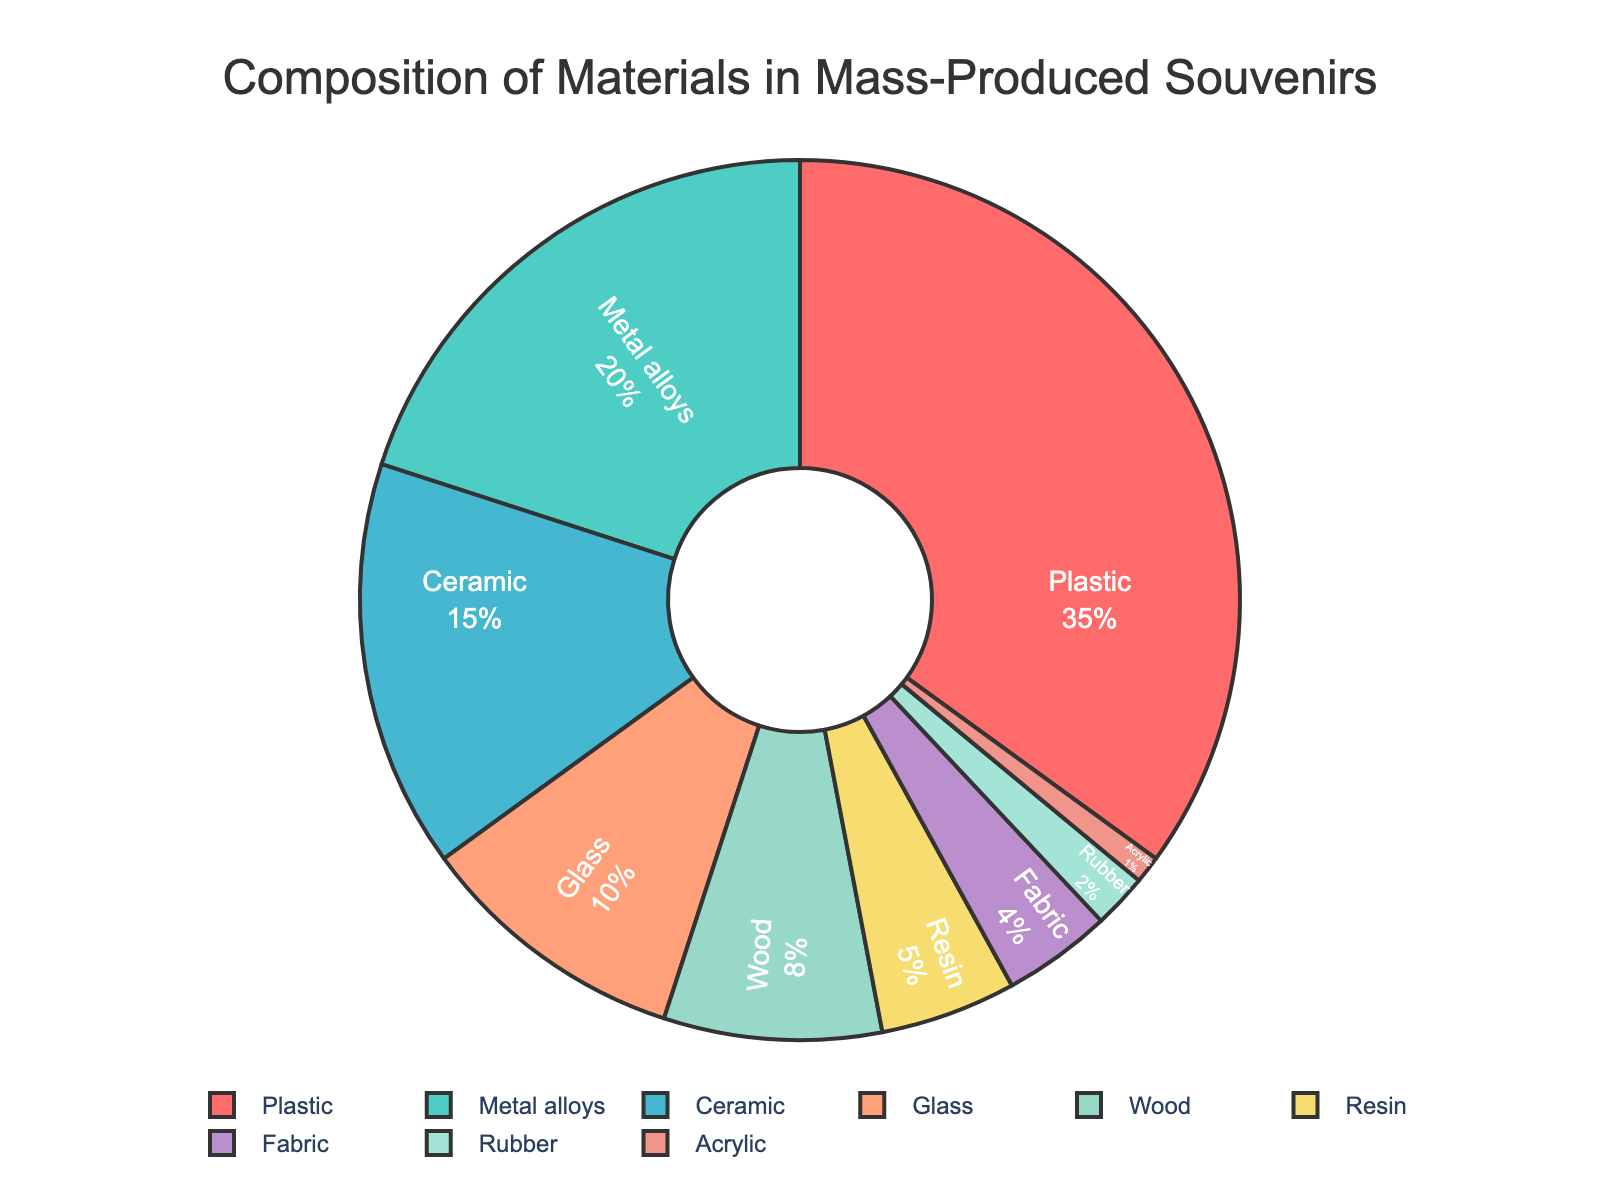What's the most commonly used material in mass-produced souvenirs? The pie chart shows the percentage distribution of various materials. By observing the chart, the material 'Plastic' stands out with the largest section.
Answer: Plastic Which material has the least percentage usage in mass-produced souvenirs? By examining the smallest segment of the pie chart, you'll find that 'Acrylic' has the smallest percentage.
Answer: Acrylic What is the sum of the percentages for Ceramic and Glass materials? From the pie chart, Ceramic is 15% and Glass is 10%. Adding these gives 15% + 10% = 25%.
Answer: 25% How much more percentage does Plastic have compared to Metal alloys? Plastic's percentage is 35%, and Metal alloys' percentage is 20%. The difference is 35% - 20% = 15%.
Answer: 15% Which three materials combined constitute exactly 50% of the total composition? Looking at the pie chart, Metal alloys (20%), Ceramic (15%), and Glass (10%) add up to 20% + 15% + 10% = 45%. Wood (8%) alone doesn’t fit this set, but adding Resin (5%) gives 50%. Therefore, Plastic (35%) and Metal alloys (20%) alone are discarded and Ceramic (15%) + Glass (10%) + Wood (8%) + Resin (5%) = 38%, and then 15% + 10% + 5% equals 30%. The combination 35% Plastic and 15% Ceramic gives 50%.
Answer: Plastic, Ceramic Which material is represented by the blue segment? The blue color segment on the pie chart corresponds to 'Metal alloys'.
Answer: Metal alloys How many materials have a percentage of less than or equal to 5%? By checking each segment of the pie chart, Resin is 5%, Fabric is 4%, Rubber is 2%, and Acrylic is 1%, giving us four materials.
Answer: Four What is the combined percentage of non-plastic organic materials (Wood and Fabric)? From the pie chart, Wood is 8% and Fabric is 4%. Combining these gives 8% + 4% = 12%.
Answer: 12% Is the portion of Rubber bigger than Fabric? Observing the pie chart, Rubber is 2% and Fabric is 4%. Fabric has a larger portion than Rubber.
Answer: No By how much does the percentage of Metal alloys exceed the combined percentage of Rubber and Acrylic? Metal alloys is 20%. Rubber is 2% and Acrylic is 1%, so their combined percentage is 2% + 1% = 3%. The difference is 20% - 3% = 17%.
Answer: 17% 